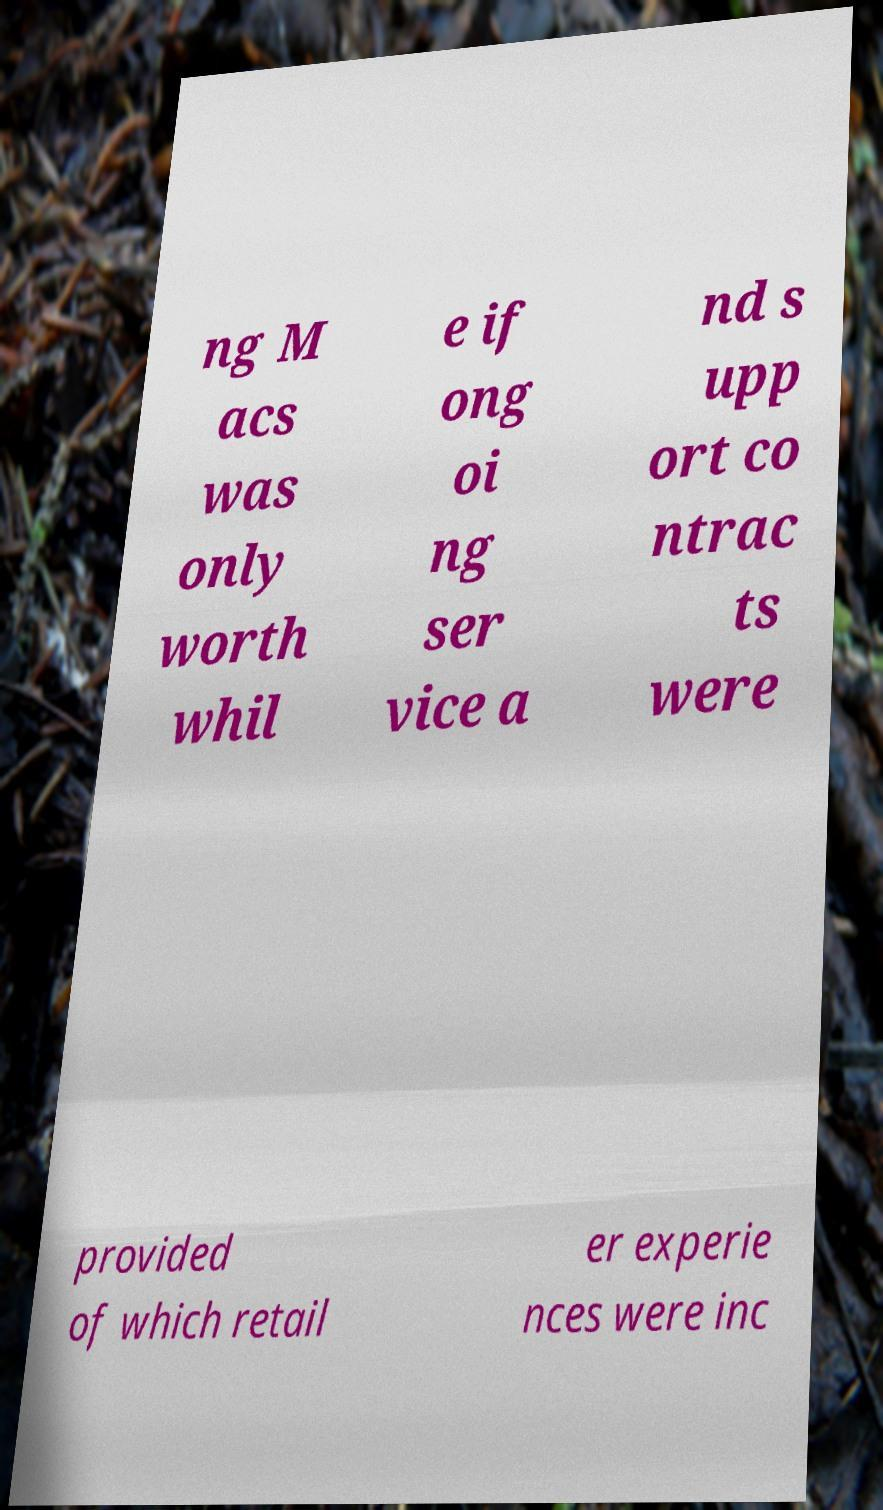Please identify and transcribe the text found in this image. ng M acs was only worth whil e if ong oi ng ser vice a nd s upp ort co ntrac ts were provided of which retail er experie nces were inc 